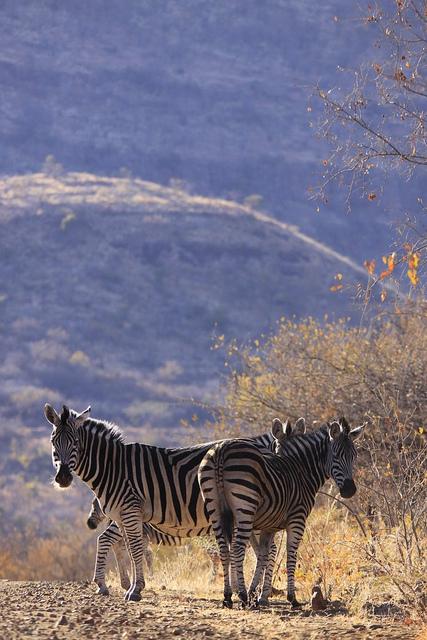Are the animals facing the same direction?
Be succinct. No. How many zebras?
Keep it brief. 4. Is this picture taken at night?
Give a very brief answer. No. What is in the background?
Quick response, please. Hill. How many animals are standing up in this image?
Quick response, please. 2. Are both of the zebras standing?
Concise answer only. Yes. 